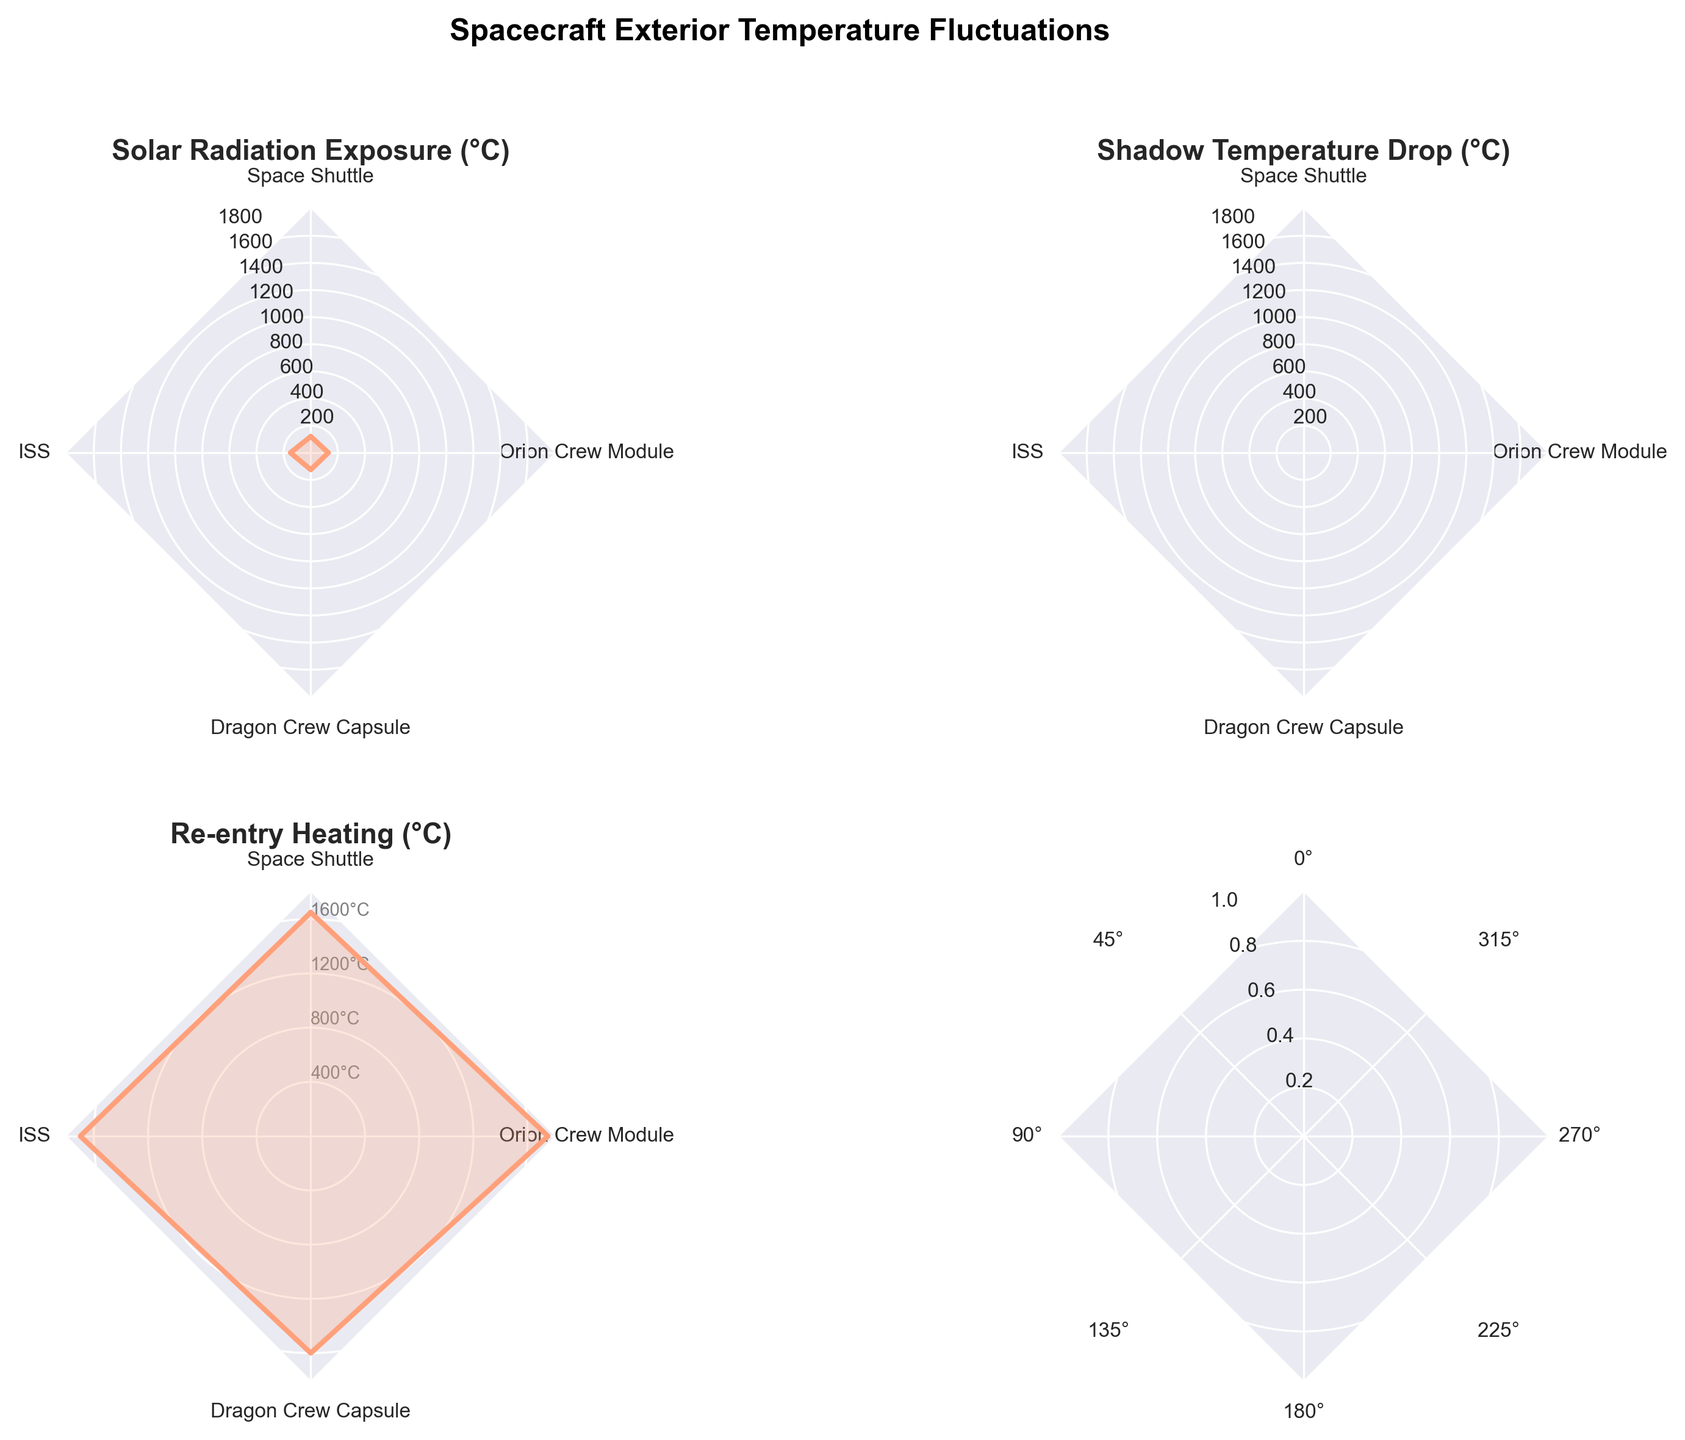Which spacecraft has the highest re-entry heating value? By observing the radar chart, locate the re-entry heating data point for all spacecraft. The Orion Crew Module has the highest value.
Answer: Orion Crew Module What is the range of the solar radiation exposure values across all spacecraft? Identify the maximum and minimum values for solar radiation exposure. The maximum is 150°C (ISS) and the minimum is 120°C (Space Shuttle). The range is 150°C - 120°C.
Answer: 30°C Which spacecraft experiences the lowest shadow temperature drop? Look for the shadow temperature drop data point across all spacecraft. The Space Shuttle has the least negative value.
Answer: Space Shuttle How does the Dragon Crew Capsule's re-entry heating compare to that of the Space Shuttle? Compare the re-entry heating values between the Dragon Crew Capsule and the Space Shuttle. The Dragon Crew Capsule has 1600°C, which is lower than the Space Shuttle's 1650°C.
Answer: Dragon Crew Capsule is lower What is the average re-entry heating value of all spacecraft? Sum the re-entry heating values for all spacecraft: 1650°C (Space Shuttle) + 1700°C (ISS) + 1600°C (Dragon Crew Capsule) + 1750°C (Orion Crew Module) = 6700°C. Divide by the number of spacecraft (4).
Answer: 1675°C Compare the solar radiation exposure of the ISS to that of the Space Shuttle. Determine the solar radiation exposure values from the radar chart. The ISS has 150°C and the Space Shuttle has 120°C, so the ISS is higher.
Answer: ISS is higher What is the difference in shadow temperature drop between the Space Shuttle and the ISS? Identify the shadow temperature drop values: -160°C (Space Shuttle) and -180°C (ISS). Compute the difference: -180°C - (-160°C) = -20°C.
Answer: 20°C Which spacecraft has the broadest range of temperature fluctuations? Compare the differences between the highest and lowest values across all categories for each spacecraft. The Orion Crew Module has the broadest range with re-entry heating at 1750°C and shadow temperature drop at -175°C.
Answer: Orion Crew Module 